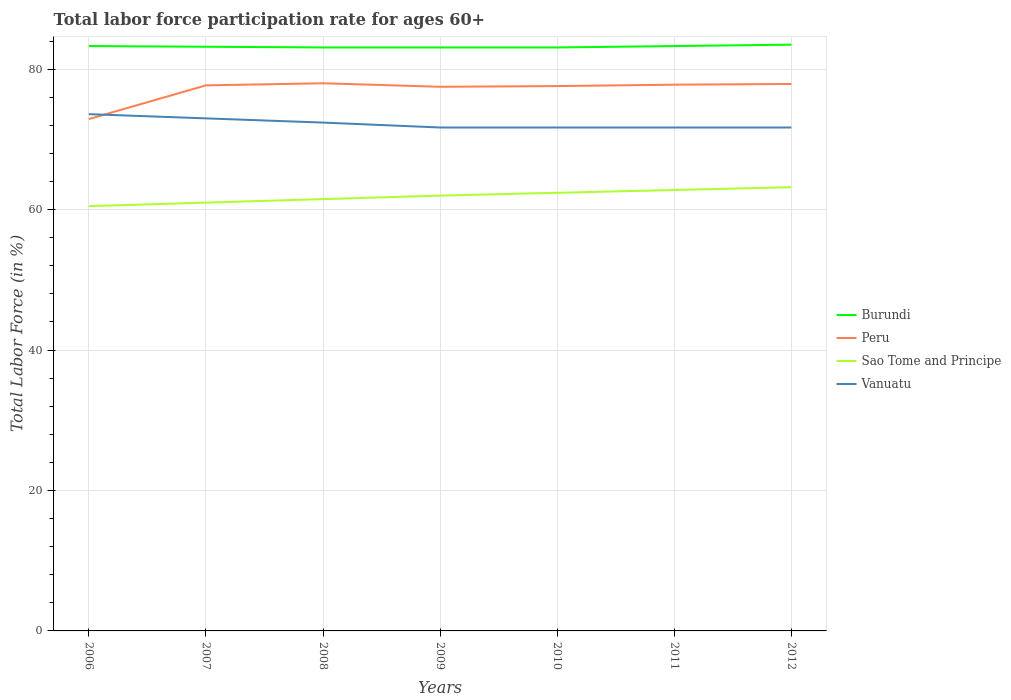Is the number of lines equal to the number of legend labels?
Your response must be concise. Yes. Across all years, what is the maximum labor force participation rate in Peru?
Your response must be concise. 72.9. In which year was the labor force participation rate in Vanuatu maximum?
Your answer should be compact. 2009. What is the total labor force participation rate in Sao Tome and Principe in the graph?
Offer a very short reply. -1.4. What is the difference between the highest and the second highest labor force participation rate in Vanuatu?
Your answer should be compact. 1.9. What is the difference between the highest and the lowest labor force participation rate in Peru?
Offer a terse response. 6. How many lines are there?
Offer a terse response. 4. How many years are there in the graph?
Provide a succinct answer. 7. Does the graph contain any zero values?
Your response must be concise. No. How many legend labels are there?
Provide a short and direct response. 4. What is the title of the graph?
Ensure brevity in your answer.  Total labor force participation rate for ages 60+. Does "World" appear as one of the legend labels in the graph?
Your answer should be compact. No. What is the Total Labor Force (in %) in Burundi in 2006?
Your response must be concise. 83.3. What is the Total Labor Force (in %) of Peru in 2006?
Provide a succinct answer. 72.9. What is the Total Labor Force (in %) of Sao Tome and Principe in 2006?
Offer a terse response. 60.5. What is the Total Labor Force (in %) in Vanuatu in 2006?
Make the answer very short. 73.6. What is the Total Labor Force (in %) in Burundi in 2007?
Your answer should be very brief. 83.2. What is the Total Labor Force (in %) of Peru in 2007?
Ensure brevity in your answer.  77.7. What is the Total Labor Force (in %) of Sao Tome and Principe in 2007?
Ensure brevity in your answer.  61. What is the Total Labor Force (in %) in Burundi in 2008?
Provide a succinct answer. 83.1. What is the Total Labor Force (in %) in Peru in 2008?
Your answer should be compact. 78. What is the Total Labor Force (in %) in Sao Tome and Principe in 2008?
Offer a very short reply. 61.5. What is the Total Labor Force (in %) of Vanuatu in 2008?
Your answer should be very brief. 72.4. What is the Total Labor Force (in %) in Burundi in 2009?
Offer a very short reply. 83.1. What is the Total Labor Force (in %) in Peru in 2009?
Offer a very short reply. 77.5. What is the Total Labor Force (in %) in Vanuatu in 2009?
Your answer should be compact. 71.7. What is the Total Labor Force (in %) in Burundi in 2010?
Provide a short and direct response. 83.1. What is the Total Labor Force (in %) in Peru in 2010?
Keep it short and to the point. 77.6. What is the Total Labor Force (in %) in Sao Tome and Principe in 2010?
Provide a short and direct response. 62.4. What is the Total Labor Force (in %) in Vanuatu in 2010?
Provide a short and direct response. 71.7. What is the Total Labor Force (in %) in Burundi in 2011?
Provide a succinct answer. 83.3. What is the Total Labor Force (in %) of Peru in 2011?
Make the answer very short. 77.8. What is the Total Labor Force (in %) of Sao Tome and Principe in 2011?
Provide a succinct answer. 62.8. What is the Total Labor Force (in %) in Vanuatu in 2011?
Provide a short and direct response. 71.7. What is the Total Labor Force (in %) in Burundi in 2012?
Give a very brief answer. 83.5. What is the Total Labor Force (in %) of Peru in 2012?
Offer a terse response. 77.9. What is the Total Labor Force (in %) in Sao Tome and Principe in 2012?
Make the answer very short. 63.2. What is the Total Labor Force (in %) in Vanuatu in 2012?
Offer a terse response. 71.7. Across all years, what is the maximum Total Labor Force (in %) in Burundi?
Provide a succinct answer. 83.5. Across all years, what is the maximum Total Labor Force (in %) of Peru?
Your response must be concise. 78. Across all years, what is the maximum Total Labor Force (in %) in Sao Tome and Principe?
Make the answer very short. 63.2. Across all years, what is the maximum Total Labor Force (in %) of Vanuatu?
Give a very brief answer. 73.6. Across all years, what is the minimum Total Labor Force (in %) in Burundi?
Offer a terse response. 83.1. Across all years, what is the minimum Total Labor Force (in %) in Peru?
Make the answer very short. 72.9. Across all years, what is the minimum Total Labor Force (in %) of Sao Tome and Principe?
Keep it short and to the point. 60.5. Across all years, what is the minimum Total Labor Force (in %) of Vanuatu?
Make the answer very short. 71.7. What is the total Total Labor Force (in %) in Burundi in the graph?
Provide a short and direct response. 582.6. What is the total Total Labor Force (in %) in Peru in the graph?
Make the answer very short. 539.4. What is the total Total Labor Force (in %) of Sao Tome and Principe in the graph?
Ensure brevity in your answer.  433.4. What is the total Total Labor Force (in %) in Vanuatu in the graph?
Your answer should be very brief. 505.8. What is the difference between the Total Labor Force (in %) of Peru in 2006 and that in 2007?
Your answer should be very brief. -4.8. What is the difference between the Total Labor Force (in %) in Burundi in 2006 and that in 2008?
Keep it short and to the point. 0.2. What is the difference between the Total Labor Force (in %) of Peru in 2006 and that in 2008?
Offer a very short reply. -5.1. What is the difference between the Total Labor Force (in %) in Sao Tome and Principe in 2006 and that in 2008?
Your response must be concise. -1. What is the difference between the Total Labor Force (in %) of Vanuatu in 2006 and that in 2008?
Your answer should be very brief. 1.2. What is the difference between the Total Labor Force (in %) of Peru in 2006 and that in 2009?
Your answer should be compact. -4.6. What is the difference between the Total Labor Force (in %) of Sao Tome and Principe in 2006 and that in 2009?
Keep it short and to the point. -1.5. What is the difference between the Total Labor Force (in %) in Burundi in 2006 and that in 2010?
Give a very brief answer. 0.2. What is the difference between the Total Labor Force (in %) of Peru in 2006 and that in 2010?
Your answer should be compact. -4.7. What is the difference between the Total Labor Force (in %) of Burundi in 2006 and that in 2011?
Ensure brevity in your answer.  0. What is the difference between the Total Labor Force (in %) of Sao Tome and Principe in 2006 and that in 2011?
Ensure brevity in your answer.  -2.3. What is the difference between the Total Labor Force (in %) of Burundi in 2006 and that in 2012?
Make the answer very short. -0.2. What is the difference between the Total Labor Force (in %) of Burundi in 2007 and that in 2008?
Keep it short and to the point. 0.1. What is the difference between the Total Labor Force (in %) of Peru in 2007 and that in 2008?
Ensure brevity in your answer.  -0.3. What is the difference between the Total Labor Force (in %) in Vanuatu in 2007 and that in 2008?
Your answer should be compact. 0.6. What is the difference between the Total Labor Force (in %) of Sao Tome and Principe in 2007 and that in 2009?
Ensure brevity in your answer.  -1. What is the difference between the Total Labor Force (in %) of Vanuatu in 2007 and that in 2009?
Your answer should be compact. 1.3. What is the difference between the Total Labor Force (in %) in Burundi in 2007 and that in 2010?
Give a very brief answer. 0.1. What is the difference between the Total Labor Force (in %) of Peru in 2007 and that in 2010?
Offer a terse response. 0.1. What is the difference between the Total Labor Force (in %) in Sao Tome and Principe in 2007 and that in 2010?
Keep it short and to the point. -1.4. What is the difference between the Total Labor Force (in %) in Vanuatu in 2007 and that in 2010?
Your response must be concise. 1.3. What is the difference between the Total Labor Force (in %) of Peru in 2007 and that in 2011?
Give a very brief answer. -0.1. What is the difference between the Total Labor Force (in %) of Sao Tome and Principe in 2007 and that in 2011?
Provide a succinct answer. -1.8. What is the difference between the Total Labor Force (in %) of Peru in 2007 and that in 2012?
Your answer should be compact. -0.2. What is the difference between the Total Labor Force (in %) of Sao Tome and Principe in 2007 and that in 2012?
Offer a very short reply. -2.2. What is the difference between the Total Labor Force (in %) of Vanuatu in 2007 and that in 2012?
Make the answer very short. 1.3. What is the difference between the Total Labor Force (in %) in Burundi in 2008 and that in 2009?
Your response must be concise. 0. What is the difference between the Total Labor Force (in %) in Sao Tome and Principe in 2008 and that in 2009?
Provide a succinct answer. -0.5. What is the difference between the Total Labor Force (in %) in Vanuatu in 2008 and that in 2010?
Provide a short and direct response. 0.7. What is the difference between the Total Labor Force (in %) in Sao Tome and Principe in 2008 and that in 2011?
Your answer should be compact. -1.3. What is the difference between the Total Labor Force (in %) of Peru in 2008 and that in 2012?
Offer a terse response. 0.1. What is the difference between the Total Labor Force (in %) of Sao Tome and Principe in 2008 and that in 2012?
Offer a very short reply. -1.7. What is the difference between the Total Labor Force (in %) of Vanuatu in 2008 and that in 2012?
Offer a terse response. 0.7. What is the difference between the Total Labor Force (in %) of Burundi in 2009 and that in 2010?
Give a very brief answer. 0. What is the difference between the Total Labor Force (in %) of Peru in 2009 and that in 2010?
Offer a terse response. -0.1. What is the difference between the Total Labor Force (in %) of Sao Tome and Principe in 2009 and that in 2010?
Ensure brevity in your answer.  -0.4. What is the difference between the Total Labor Force (in %) in Vanuatu in 2009 and that in 2011?
Provide a succinct answer. 0. What is the difference between the Total Labor Force (in %) in Burundi in 2009 and that in 2012?
Your response must be concise. -0.4. What is the difference between the Total Labor Force (in %) in Peru in 2009 and that in 2012?
Provide a succinct answer. -0.4. What is the difference between the Total Labor Force (in %) of Sao Tome and Principe in 2009 and that in 2012?
Ensure brevity in your answer.  -1.2. What is the difference between the Total Labor Force (in %) of Peru in 2010 and that in 2011?
Your answer should be compact. -0.2. What is the difference between the Total Labor Force (in %) in Peru in 2010 and that in 2012?
Offer a very short reply. -0.3. What is the difference between the Total Labor Force (in %) in Sao Tome and Principe in 2010 and that in 2012?
Your answer should be compact. -0.8. What is the difference between the Total Labor Force (in %) in Vanuatu in 2010 and that in 2012?
Ensure brevity in your answer.  0. What is the difference between the Total Labor Force (in %) of Burundi in 2011 and that in 2012?
Provide a succinct answer. -0.2. What is the difference between the Total Labor Force (in %) of Peru in 2011 and that in 2012?
Offer a terse response. -0.1. What is the difference between the Total Labor Force (in %) in Burundi in 2006 and the Total Labor Force (in %) in Peru in 2007?
Give a very brief answer. 5.6. What is the difference between the Total Labor Force (in %) in Burundi in 2006 and the Total Labor Force (in %) in Sao Tome and Principe in 2007?
Your answer should be very brief. 22.3. What is the difference between the Total Labor Force (in %) of Burundi in 2006 and the Total Labor Force (in %) of Vanuatu in 2007?
Offer a terse response. 10.3. What is the difference between the Total Labor Force (in %) in Peru in 2006 and the Total Labor Force (in %) in Sao Tome and Principe in 2007?
Provide a short and direct response. 11.9. What is the difference between the Total Labor Force (in %) of Sao Tome and Principe in 2006 and the Total Labor Force (in %) of Vanuatu in 2007?
Your answer should be very brief. -12.5. What is the difference between the Total Labor Force (in %) in Burundi in 2006 and the Total Labor Force (in %) in Peru in 2008?
Make the answer very short. 5.3. What is the difference between the Total Labor Force (in %) in Burundi in 2006 and the Total Labor Force (in %) in Sao Tome and Principe in 2008?
Give a very brief answer. 21.8. What is the difference between the Total Labor Force (in %) of Burundi in 2006 and the Total Labor Force (in %) of Vanuatu in 2008?
Your response must be concise. 10.9. What is the difference between the Total Labor Force (in %) of Peru in 2006 and the Total Labor Force (in %) of Sao Tome and Principe in 2008?
Your answer should be very brief. 11.4. What is the difference between the Total Labor Force (in %) of Peru in 2006 and the Total Labor Force (in %) of Vanuatu in 2008?
Keep it short and to the point. 0.5. What is the difference between the Total Labor Force (in %) of Sao Tome and Principe in 2006 and the Total Labor Force (in %) of Vanuatu in 2008?
Offer a terse response. -11.9. What is the difference between the Total Labor Force (in %) of Burundi in 2006 and the Total Labor Force (in %) of Sao Tome and Principe in 2009?
Your answer should be compact. 21.3. What is the difference between the Total Labor Force (in %) of Burundi in 2006 and the Total Labor Force (in %) of Vanuatu in 2009?
Your answer should be compact. 11.6. What is the difference between the Total Labor Force (in %) in Peru in 2006 and the Total Labor Force (in %) in Vanuatu in 2009?
Provide a succinct answer. 1.2. What is the difference between the Total Labor Force (in %) in Sao Tome and Principe in 2006 and the Total Labor Force (in %) in Vanuatu in 2009?
Give a very brief answer. -11.2. What is the difference between the Total Labor Force (in %) in Burundi in 2006 and the Total Labor Force (in %) in Peru in 2010?
Offer a very short reply. 5.7. What is the difference between the Total Labor Force (in %) in Burundi in 2006 and the Total Labor Force (in %) in Sao Tome and Principe in 2010?
Your answer should be very brief. 20.9. What is the difference between the Total Labor Force (in %) in Sao Tome and Principe in 2006 and the Total Labor Force (in %) in Vanuatu in 2010?
Your answer should be very brief. -11.2. What is the difference between the Total Labor Force (in %) in Peru in 2006 and the Total Labor Force (in %) in Sao Tome and Principe in 2011?
Give a very brief answer. 10.1. What is the difference between the Total Labor Force (in %) of Peru in 2006 and the Total Labor Force (in %) of Vanuatu in 2011?
Give a very brief answer. 1.2. What is the difference between the Total Labor Force (in %) in Burundi in 2006 and the Total Labor Force (in %) in Peru in 2012?
Provide a short and direct response. 5.4. What is the difference between the Total Labor Force (in %) in Burundi in 2006 and the Total Labor Force (in %) in Sao Tome and Principe in 2012?
Ensure brevity in your answer.  20.1. What is the difference between the Total Labor Force (in %) in Peru in 2006 and the Total Labor Force (in %) in Vanuatu in 2012?
Your answer should be very brief. 1.2. What is the difference between the Total Labor Force (in %) in Sao Tome and Principe in 2006 and the Total Labor Force (in %) in Vanuatu in 2012?
Your answer should be very brief. -11.2. What is the difference between the Total Labor Force (in %) in Burundi in 2007 and the Total Labor Force (in %) in Sao Tome and Principe in 2008?
Your response must be concise. 21.7. What is the difference between the Total Labor Force (in %) of Burundi in 2007 and the Total Labor Force (in %) of Vanuatu in 2008?
Give a very brief answer. 10.8. What is the difference between the Total Labor Force (in %) of Peru in 2007 and the Total Labor Force (in %) of Vanuatu in 2008?
Offer a very short reply. 5.3. What is the difference between the Total Labor Force (in %) of Burundi in 2007 and the Total Labor Force (in %) of Sao Tome and Principe in 2009?
Offer a very short reply. 21.2. What is the difference between the Total Labor Force (in %) in Peru in 2007 and the Total Labor Force (in %) in Sao Tome and Principe in 2009?
Keep it short and to the point. 15.7. What is the difference between the Total Labor Force (in %) in Peru in 2007 and the Total Labor Force (in %) in Vanuatu in 2009?
Offer a terse response. 6. What is the difference between the Total Labor Force (in %) of Burundi in 2007 and the Total Labor Force (in %) of Peru in 2010?
Your response must be concise. 5.6. What is the difference between the Total Labor Force (in %) of Burundi in 2007 and the Total Labor Force (in %) of Sao Tome and Principe in 2010?
Ensure brevity in your answer.  20.8. What is the difference between the Total Labor Force (in %) of Peru in 2007 and the Total Labor Force (in %) of Sao Tome and Principe in 2010?
Ensure brevity in your answer.  15.3. What is the difference between the Total Labor Force (in %) of Peru in 2007 and the Total Labor Force (in %) of Vanuatu in 2010?
Your answer should be very brief. 6. What is the difference between the Total Labor Force (in %) of Burundi in 2007 and the Total Labor Force (in %) of Sao Tome and Principe in 2011?
Provide a succinct answer. 20.4. What is the difference between the Total Labor Force (in %) of Peru in 2007 and the Total Labor Force (in %) of Vanuatu in 2011?
Provide a short and direct response. 6. What is the difference between the Total Labor Force (in %) of Sao Tome and Principe in 2007 and the Total Labor Force (in %) of Vanuatu in 2011?
Provide a succinct answer. -10.7. What is the difference between the Total Labor Force (in %) of Burundi in 2007 and the Total Labor Force (in %) of Vanuatu in 2012?
Provide a short and direct response. 11.5. What is the difference between the Total Labor Force (in %) in Peru in 2007 and the Total Labor Force (in %) in Sao Tome and Principe in 2012?
Ensure brevity in your answer.  14.5. What is the difference between the Total Labor Force (in %) in Sao Tome and Principe in 2007 and the Total Labor Force (in %) in Vanuatu in 2012?
Provide a short and direct response. -10.7. What is the difference between the Total Labor Force (in %) of Burundi in 2008 and the Total Labor Force (in %) of Sao Tome and Principe in 2009?
Your answer should be very brief. 21.1. What is the difference between the Total Labor Force (in %) in Burundi in 2008 and the Total Labor Force (in %) in Vanuatu in 2009?
Your answer should be very brief. 11.4. What is the difference between the Total Labor Force (in %) in Peru in 2008 and the Total Labor Force (in %) in Sao Tome and Principe in 2009?
Ensure brevity in your answer.  16. What is the difference between the Total Labor Force (in %) of Peru in 2008 and the Total Labor Force (in %) of Vanuatu in 2009?
Your answer should be compact. 6.3. What is the difference between the Total Labor Force (in %) of Burundi in 2008 and the Total Labor Force (in %) of Sao Tome and Principe in 2010?
Your answer should be very brief. 20.7. What is the difference between the Total Labor Force (in %) in Burundi in 2008 and the Total Labor Force (in %) in Sao Tome and Principe in 2011?
Offer a terse response. 20.3. What is the difference between the Total Labor Force (in %) in Peru in 2008 and the Total Labor Force (in %) in Vanuatu in 2011?
Your answer should be compact. 6.3. What is the difference between the Total Labor Force (in %) of Peru in 2008 and the Total Labor Force (in %) of Sao Tome and Principe in 2012?
Ensure brevity in your answer.  14.8. What is the difference between the Total Labor Force (in %) of Burundi in 2009 and the Total Labor Force (in %) of Peru in 2010?
Keep it short and to the point. 5.5. What is the difference between the Total Labor Force (in %) in Burundi in 2009 and the Total Labor Force (in %) in Sao Tome and Principe in 2010?
Your answer should be very brief. 20.7. What is the difference between the Total Labor Force (in %) of Peru in 2009 and the Total Labor Force (in %) of Sao Tome and Principe in 2010?
Offer a very short reply. 15.1. What is the difference between the Total Labor Force (in %) of Peru in 2009 and the Total Labor Force (in %) of Vanuatu in 2010?
Make the answer very short. 5.8. What is the difference between the Total Labor Force (in %) of Burundi in 2009 and the Total Labor Force (in %) of Peru in 2011?
Make the answer very short. 5.3. What is the difference between the Total Labor Force (in %) in Burundi in 2009 and the Total Labor Force (in %) in Sao Tome and Principe in 2011?
Keep it short and to the point. 20.3. What is the difference between the Total Labor Force (in %) of Burundi in 2009 and the Total Labor Force (in %) of Vanuatu in 2011?
Provide a short and direct response. 11.4. What is the difference between the Total Labor Force (in %) in Peru in 2009 and the Total Labor Force (in %) in Vanuatu in 2011?
Your answer should be compact. 5.8. What is the difference between the Total Labor Force (in %) of Burundi in 2009 and the Total Labor Force (in %) of Sao Tome and Principe in 2012?
Your answer should be compact. 19.9. What is the difference between the Total Labor Force (in %) in Burundi in 2009 and the Total Labor Force (in %) in Vanuatu in 2012?
Offer a terse response. 11.4. What is the difference between the Total Labor Force (in %) in Peru in 2009 and the Total Labor Force (in %) in Sao Tome and Principe in 2012?
Your answer should be compact. 14.3. What is the difference between the Total Labor Force (in %) of Peru in 2009 and the Total Labor Force (in %) of Vanuatu in 2012?
Offer a terse response. 5.8. What is the difference between the Total Labor Force (in %) of Sao Tome and Principe in 2009 and the Total Labor Force (in %) of Vanuatu in 2012?
Your response must be concise. -9.7. What is the difference between the Total Labor Force (in %) in Burundi in 2010 and the Total Labor Force (in %) in Peru in 2011?
Keep it short and to the point. 5.3. What is the difference between the Total Labor Force (in %) in Burundi in 2010 and the Total Labor Force (in %) in Sao Tome and Principe in 2011?
Offer a very short reply. 20.3. What is the difference between the Total Labor Force (in %) of Burundi in 2010 and the Total Labor Force (in %) of Vanuatu in 2011?
Offer a very short reply. 11.4. What is the difference between the Total Labor Force (in %) of Sao Tome and Principe in 2010 and the Total Labor Force (in %) of Vanuatu in 2012?
Provide a succinct answer. -9.3. What is the difference between the Total Labor Force (in %) of Burundi in 2011 and the Total Labor Force (in %) of Sao Tome and Principe in 2012?
Make the answer very short. 20.1. What is the difference between the Total Labor Force (in %) in Burundi in 2011 and the Total Labor Force (in %) in Vanuatu in 2012?
Provide a succinct answer. 11.6. What is the average Total Labor Force (in %) of Burundi per year?
Provide a succinct answer. 83.23. What is the average Total Labor Force (in %) in Peru per year?
Make the answer very short. 77.06. What is the average Total Labor Force (in %) of Sao Tome and Principe per year?
Ensure brevity in your answer.  61.91. What is the average Total Labor Force (in %) in Vanuatu per year?
Keep it short and to the point. 72.26. In the year 2006, what is the difference between the Total Labor Force (in %) of Burundi and Total Labor Force (in %) of Sao Tome and Principe?
Ensure brevity in your answer.  22.8. In the year 2007, what is the difference between the Total Labor Force (in %) of Burundi and Total Labor Force (in %) of Peru?
Give a very brief answer. 5.5. In the year 2007, what is the difference between the Total Labor Force (in %) of Burundi and Total Labor Force (in %) of Sao Tome and Principe?
Offer a very short reply. 22.2. In the year 2007, what is the difference between the Total Labor Force (in %) of Peru and Total Labor Force (in %) of Sao Tome and Principe?
Your response must be concise. 16.7. In the year 2007, what is the difference between the Total Labor Force (in %) in Peru and Total Labor Force (in %) in Vanuatu?
Provide a short and direct response. 4.7. In the year 2007, what is the difference between the Total Labor Force (in %) in Sao Tome and Principe and Total Labor Force (in %) in Vanuatu?
Provide a short and direct response. -12. In the year 2008, what is the difference between the Total Labor Force (in %) of Burundi and Total Labor Force (in %) of Peru?
Offer a terse response. 5.1. In the year 2008, what is the difference between the Total Labor Force (in %) of Burundi and Total Labor Force (in %) of Sao Tome and Principe?
Keep it short and to the point. 21.6. In the year 2008, what is the difference between the Total Labor Force (in %) in Peru and Total Labor Force (in %) in Sao Tome and Principe?
Ensure brevity in your answer.  16.5. In the year 2008, what is the difference between the Total Labor Force (in %) of Peru and Total Labor Force (in %) of Vanuatu?
Offer a very short reply. 5.6. In the year 2008, what is the difference between the Total Labor Force (in %) of Sao Tome and Principe and Total Labor Force (in %) of Vanuatu?
Ensure brevity in your answer.  -10.9. In the year 2009, what is the difference between the Total Labor Force (in %) of Burundi and Total Labor Force (in %) of Sao Tome and Principe?
Keep it short and to the point. 21.1. In the year 2009, what is the difference between the Total Labor Force (in %) of Peru and Total Labor Force (in %) of Vanuatu?
Your answer should be very brief. 5.8. In the year 2009, what is the difference between the Total Labor Force (in %) of Sao Tome and Principe and Total Labor Force (in %) of Vanuatu?
Your response must be concise. -9.7. In the year 2010, what is the difference between the Total Labor Force (in %) in Burundi and Total Labor Force (in %) in Sao Tome and Principe?
Keep it short and to the point. 20.7. In the year 2010, what is the difference between the Total Labor Force (in %) in Burundi and Total Labor Force (in %) in Vanuatu?
Your answer should be compact. 11.4. In the year 2010, what is the difference between the Total Labor Force (in %) in Peru and Total Labor Force (in %) in Sao Tome and Principe?
Provide a succinct answer. 15.2. In the year 2010, what is the difference between the Total Labor Force (in %) in Peru and Total Labor Force (in %) in Vanuatu?
Your answer should be compact. 5.9. In the year 2010, what is the difference between the Total Labor Force (in %) of Sao Tome and Principe and Total Labor Force (in %) of Vanuatu?
Make the answer very short. -9.3. In the year 2011, what is the difference between the Total Labor Force (in %) in Burundi and Total Labor Force (in %) in Sao Tome and Principe?
Make the answer very short. 20.5. In the year 2011, what is the difference between the Total Labor Force (in %) of Peru and Total Labor Force (in %) of Sao Tome and Principe?
Offer a terse response. 15. In the year 2011, what is the difference between the Total Labor Force (in %) in Peru and Total Labor Force (in %) in Vanuatu?
Offer a very short reply. 6.1. In the year 2011, what is the difference between the Total Labor Force (in %) in Sao Tome and Principe and Total Labor Force (in %) in Vanuatu?
Give a very brief answer. -8.9. In the year 2012, what is the difference between the Total Labor Force (in %) of Burundi and Total Labor Force (in %) of Peru?
Offer a terse response. 5.6. In the year 2012, what is the difference between the Total Labor Force (in %) in Burundi and Total Labor Force (in %) in Sao Tome and Principe?
Offer a terse response. 20.3. In the year 2012, what is the difference between the Total Labor Force (in %) of Burundi and Total Labor Force (in %) of Vanuatu?
Provide a succinct answer. 11.8. In the year 2012, what is the difference between the Total Labor Force (in %) of Peru and Total Labor Force (in %) of Sao Tome and Principe?
Your response must be concise. 14.7. In the year 2012, what is the difference between the Total Labor Force (in %) of Peru and Total Labor Force (in %) of Vanuatu?
Provide a short and direct response. 6.2. In the year 2012, what is the difference between the Total Labor Force (in %) in Sao Tome and Principe and Total Labor Force (in %) in Vanuatu?
Provide a short and direct response. -8.5. What is the ratio of the Total Labor Force (in %) in Burundi in 2006 to that in 2007?
Provide a short and direct response. 1. What is the ratio of the Total Labor Force (in %) of Peru in 2006 to that in 2007?
Keep it short and to the point. 0.94. What is the ratio of the Total Labor Force (in %) in Sao Tome and Principe in 2006 to that in 2007?
Provide a succinct answer. 0.99. What is the ratio of the Total Labor Force (in %) of Vanuatu in 2006 to that in 2007?
Offer a very short reply. 1.01. What is the ratio of the Total Labor Force (in %) of Burundi in 2006 to that in 2008?
Offer a very short reply. 1. What is the ratio of the Total Labor Force (in %) of Peru in 2006 to that in 2008?
Provide a succinct answer. 0.93. What is the ratio of the Total Labor Force (in %) in Sao Tome and Principe in 2006 to that in 2008?
Provide a short and direct response. 0.98. What is the ratio of the Total Labor Force (in %) of Vanuatu in 2006 to that in 2008?
Provide a succinct answer. 1.02. What is the ratio of the Total Labor Force (in %) of Burundi in 2006 to that in 2009?
Your answer should be compact. 1. What is the ratio of the Total Labor Force (in %) in Peru in 2006 to that in 2009?
Your answer should be compact. 0.94. What is the ratio of the Total Labor Force (in %) of Sao Tome and Principe in 2006 to that in 2009?
Keep it short and to the point. 0.98. What is the ratio of the Total Labor Force (in %) of Vanuatu in 2006 to that in 2009?
Offer a terse response. 1.03. What is the ratio of the Total Labor Force (in %) of Burundi in 2006 to that in 2010?
Keep it short and to the point. 1. What is the ratio of the Total Labor Force (in %) in Peru in 2006 to that in 2010?
Offer a very short reply. 0.94. What is the ratio of the Total Labor Force (in %) in Sao Tome and Principe in 2006 to that in 2010?
Give a very brief answer. 0.97. What is the ratio of the Total Labor Force (in %) in Vanuatu in 2006 to that in 2010?
Ensure brevity in your answer.  1.03. What is the ratio of the Total Labor Force (in %) of Peru in 2006 to that in 2011?
Your response must be concise. 0.94. What is the ratio of the Total Labor Force (in %) in Sao Tome and Principe in 2006 to that in 2011?
Give a very brief answer. 0.96. What is the ratio of the Total Labor Force (in %) in Vanuatu in 2006 to that in 2011?
Make the answer very short. 1.03. What is the ratio of the Total Labor Force (in %) in Peru in 2006 to that in 2012?
Offer a very short reply. 0.94. What is the ratio of the Total Labor Force (in %) in Sao Tome and Principe in 2006 to that in 2012?
Provide a short and direct response. 0.96. What is the ratio of the Total Labor Force (in %) of Vanuatu in 2006 to that in 2012?
Offer a very short reply. 1.03. What is the ratio of the Total Labor Force (in %) of Sao Tome and Principe in 2007 to that in 2008?
Make the answer very short. 0.99. What is the ratio of the Total Labor Force (in %) of Vanuatu in 2007 to that in 2008?
Provide a succinct answer. 1.01. What is the ratio of the Total Labor Force (in %) in Burundi in 2007 to that in 2009?
Your answer should be very brief. 1. What is the ratio of the Total Labor Force (in %) of Sao Tome and Principe in 2007 to that in 2009?
Provide a succinct answer. 0.98. What is the ratio of the Total Labor Force (in %) in Vanuatu in 2007 to that in 2009?
Your response must be concise. 1.02. What is the ratio of the Total Labor Force (in %) of Burundi in 2007 to that in 2010?
Offer a very short reply. 1. What is the ratio of the Total Labor Force (in %) of Peru in 2007 to that in 2010?
Offer a terse response. 1. What is the ratio of the Total Labor Force (in %) of Sao Tome and Principe in 2007 to that in 2010?
Give a very brief answer. 0.98. What is the ratio of the Total Labor Force (in %) of Vanuatu in 2007 to that in 2010?
Your response must be concise. 1.02. What is the ratio of the Total Labor Force (in %) of Burundi in 2007 to that in 2011?
Provide a succinct answer. 1. What is the ratio of the Total Labor Force (in %) in Peru in 2007 to that in 2011?
Keep it short and to the point. 1. What is the ratio of the Total Labor Force (in %) in Sao Tome and Principe in 2007 to that in 2011?
Your response must be concise. 0.97. What is the ratio of the Total Labor Force (in %) in Vanuatu in 2007 to that in 2011?
Provide a short and direct response. 1.02. What is the ratio of the Total Labor Force (in %) of Peru in 2007 to that in 2012?
Give a very brief answer. 1. What is the ratio of the Total Labor Force (in %) of Sao Tome and Principe in 2007 to that in 2012?
Your answer should be compact. 0.97. What is the ratio of the Total Labor Force (in %) in Vanuatu in 2007 to that in 2012?
Make the answer very short. 1.02. What is the ratio of the Total Labor Force (in %) of Sao Tome and Principe in 2008 to that in 2009?
Give a very brief answer. 0.99. What is the ratio of the Total Labor Force (in %) in Vanuatu in 2008 to that in 2009?
Offer a very short reply. 1.01. What is the ratio of the Total Labor Force (in %) in Burundi in 2008 to that in 2010?
Your answer should be very brief. 1. What is the ratio of the Total Labor Force (in %) in Sao Tome and Principe in 2008 to that in 2010?
Your answer should be compact. 0.99. What is the ratio of the Total Labor Force (in %) of Vanuatu in 2008 to that in 2010?
Your answer should be very brief. 1.01. What is the ratio of the Total Labor Force (in %) in Peru in 2008 to that in 2011?
Keep it short and to the point. 1. What is the ratio of the Total Labor Force (in %) of Sao Tome and Principe in 2008 to that in 2011?
Offer a very short reply. 0.98. What is the ratio of the Total Labor Force (in %) in Vanuatu in 2008 to that in 2011?
Offer a very short reply. 1.01. What is the ratio of the Total Labor Force (in %) of Peru in 2008 to that in 2012?
Keep it short and to the point. 1. What is the ratio of the Total Labor Force (in %) of Sao Tome and Principe in 2008 to that in 2012?
Offer a terse response. 0.97. What is the ratio of the Total Labor Force (in %) in Vanuatu in 2008 to that in 2012?
Offer a terse response. 1.01. What is the ratio of the Total Labor Force (in %) in Peru in 2009 to that in 2010?
Give a very brief answer. 1. What is the ratio of the Total Labor Force (in %) in Vanuatu in 2009 to that in 2010?
Give a very brief answer. 1. What is the ratio of the Total Labor Force (in %) of Sao Tome and Principe in 2009 to that in 2011?
Your response must be concise. 0.99. What is the ratio of the Total Labor Force (in %) in Vanuatu in 2009 to that in 2011?
Your answer should be compact. 1. What is the ratio of the Total Labor Force (in %) of Burundi in 2009 to that in 2012?
Make the answer very short. 1. What is the ratio of the Total Labor Force (in %) in Peru in 2009 to that in 2012?
Your answer should be very brief. 0.99. What is the ratio of the Total Labor Force (in %) in Sao Tome and Principe in 2009 to that in 2012?
Your answer should be compact. 0.98. What is the ratio of the Total Labor Force (in %) in Vanuatu in 2009 to that in 2012?
Offer a terse response. 1. What is the ratio of the Total Labor Force (in %) in Burundi in 2010 to that in 2011?
Give a very brief answer. 1. What is the ratio of the Total Labor Force (in %) of Sao Tome and Principe in 2010 to that in 2011?
Provide a short and direct response. 0.99. What is the ratio of the Total Labor Force (in %) in Burundi in 2010 to that in 2012?
Give a very brief answer. 1. What is the ratio of the Total Labor Force (in %) of Peru in 2010 to that in 2012?
Make the answer very short. 1. What is the ratio of the Total Labor Force (in %) of Sao Tome and Principe in 2010 to that in 2012?
Your answer should be compact. 0.99. What is the ratio of the Total Labor Force (in %) of Burundi in 2011 to that in 2012?
Your response must be concise. 1. What is the ratio of the Total Labor Force (in %) of Sao Tome and Principe in 2011 to that in 2012?
Give a very brief answer. 0.99. What is the difference between the highest and the second highest Total Labor Force (in %) in Burundi?
Ensure brevity in your answer.  0.2. What is the difference between the highest and the second highest Total Labor Force (in %) of Sao Tome and Principe?
Offer a terse response. 0.4. What is the difference between the highest and the second highest Total Labor Force (in %) of Vanuatu?
Your answer should be very brief. 0.6. What is the difference between the highest and the lowest Total Labor Force (in %) in Vanuatu?
Offer a very short reply. 1.9. 